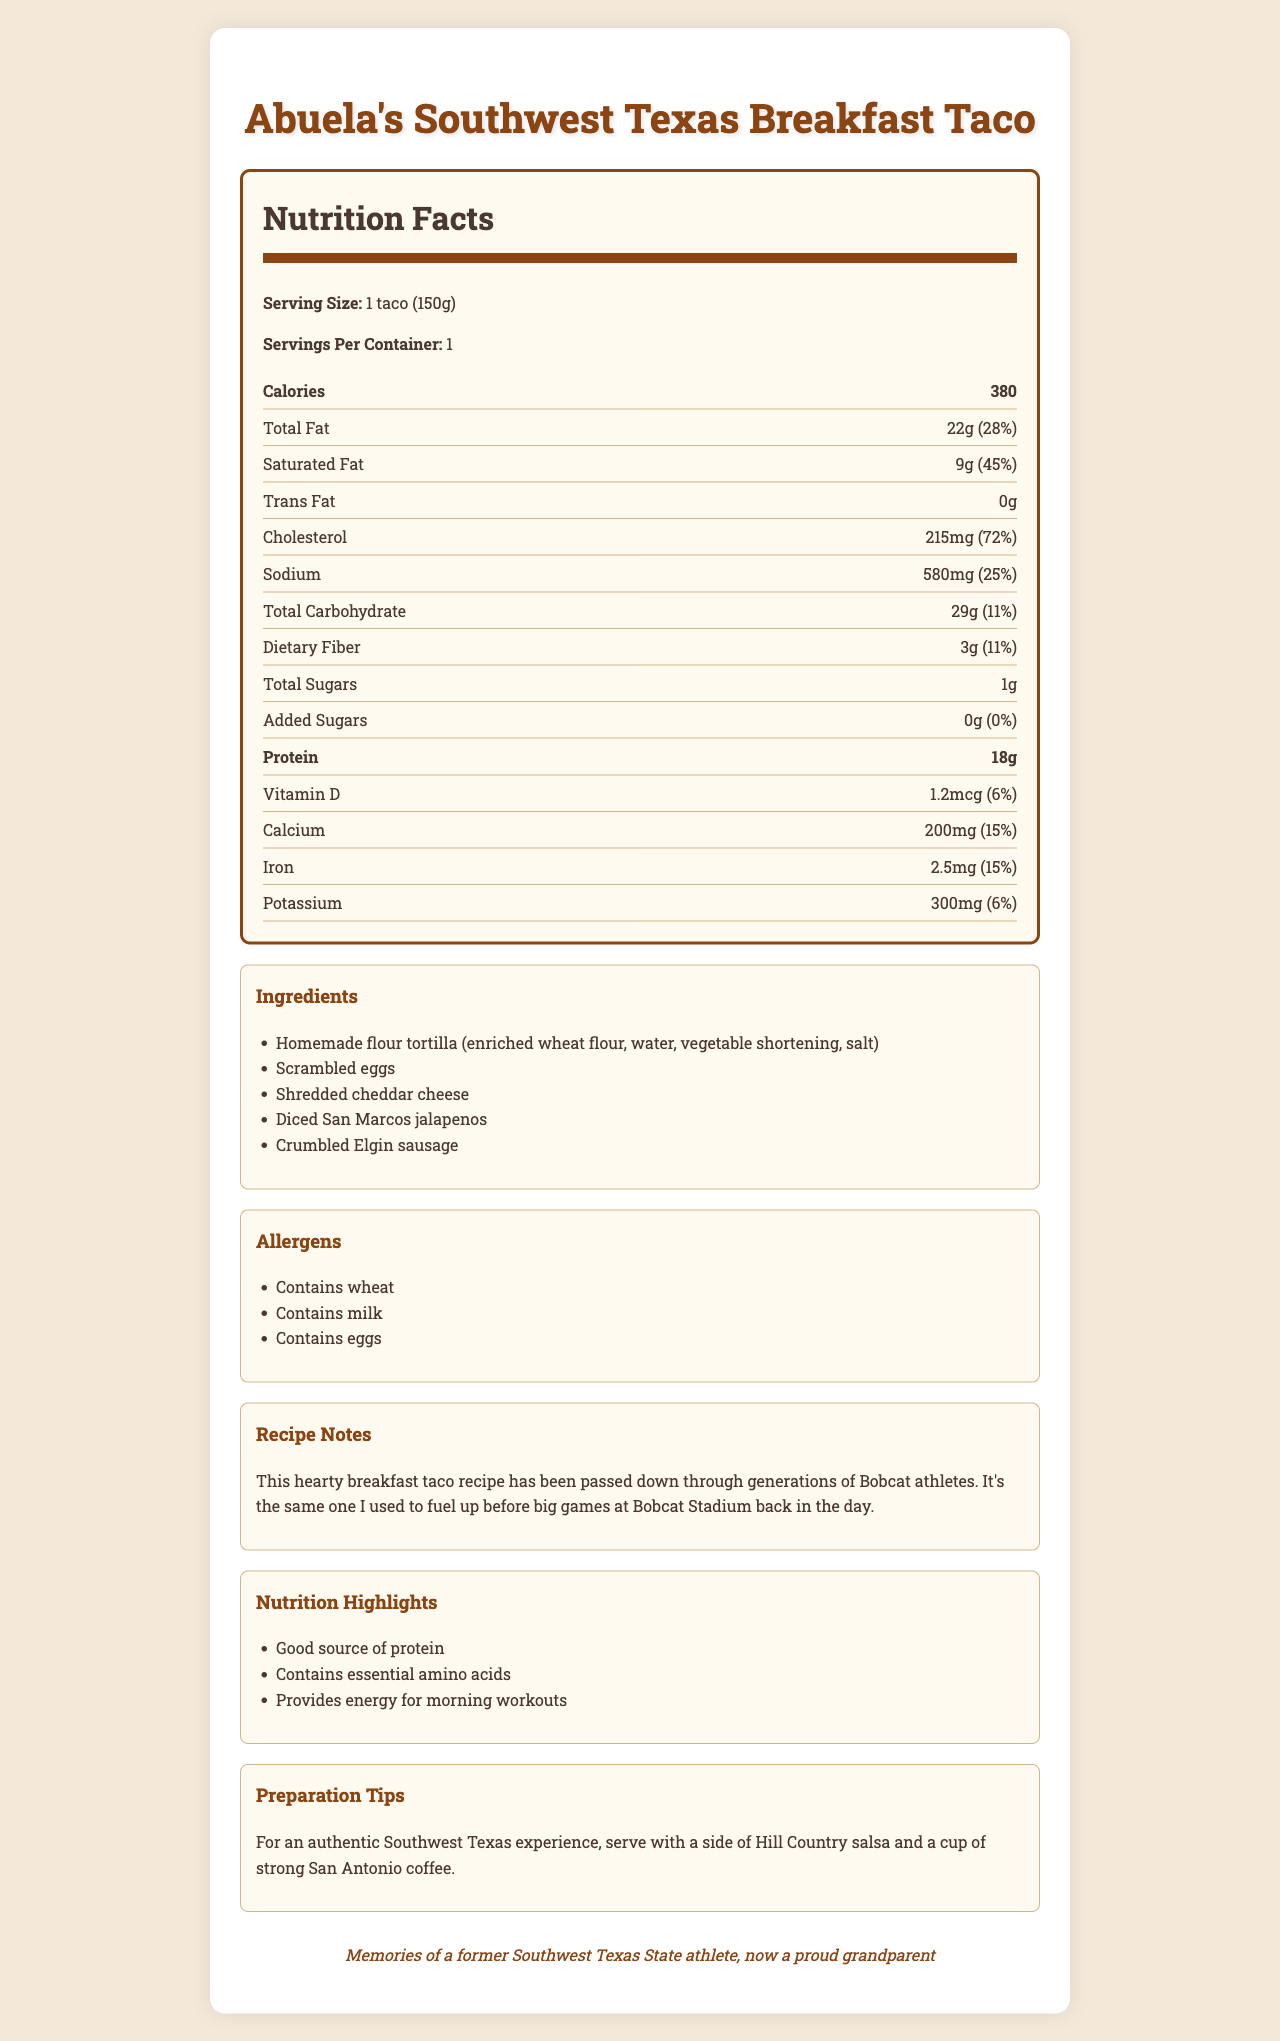what is the serving size for Abuela's Southwest Texas Breakfast Taco? The serving size information is clearly stated in the document.
Answer: 1 taco (150g) how much total fat does one taco contain? The document lists total fat content as 22 grams.
Answer: 22g what percentage of the daily value of dietary fiber does one taco provide? The document states that the dietary fiber is 3 grams, which is 11% of the daily value.
Answer: 11% how much protein is in one breakfast taco? The document specifies that one taco contains 18 grams of protein.
Answer: 18g what are the main ingredients in the breakfast taco? The main ingredients are listed under the "Ingredients" section.
Answer: Homemade flour tortilla, scrambled eggs, shredded cheddar cheese, diced San Marcos jalapenos, crumbled Elgin sausage what is the amount of sodium in one taco? The sodium content is listed as 580 milligrams.
Answer: 580mg what are the allergens mentioned in the document? The allergens section mentions that the product contains wheat, milk, and eggs.
Answer: Wheat, milk, eggs how many calories does one breakfast taco contain? The document states that there are 380 calories in one serving.
Answer: 380 what is the main source of calcium in the breakfast taco? A. Scrambled eggs B. Shredded cheddar cheese C. Homemade flour tortilla D. Diced San Marcos jalapenos The shredded cheddar cheese is likely the main source of calcium.
Answer: B which nutrient has the highest daily value percentage? i. Vitamin D ii. Calcium iii. Iron iv. Cholesterol Cholesterol has the highest daily value percentage at 72%.
Answer: iv does the document provide preparation tips for the breakfast taco? The "Preparation Tips" section gives recommendations for an authentic Southwest Texas experience.
Answer: Yes is the breakfast taco a good source of protein? The nutrition highlights section states "Good source of protein."
Answer: Yes explain the main purpose of this document The main purpose is to inform readers about the nutritional content and ingredients of the breakfast taco, while also sharing personal memories and cultural context associated with the recipe.
Answer: The document provides detailed nutritional information about Abuela's Southwest Texas Breakfast Taco, including ingredients, allergens, and preparation tips. It includes a nostalgic note from a former Southwest Texas State athlete and highlights the breakfast taco's nutritional benefits for energy and protein. how much saturated fat does the taco contain? The document lists the saturated fat content as 9 grams.
Answer: 9g how many grams of dietary fiber are in one taco? The dietary fiber content is listed as 3 grams.
Answer: 3g what type of coffee is recommended to be served with the breakfast taco? The preparation tips section suggests serving with a cup of strong San Antonio coffee.
Answer: San Antonio coffee what percentage of the daily value of protein does the taco provide? The document lists the amount of protein but does not specify the percentage of the daily value.
Answer: Cannot be determined 